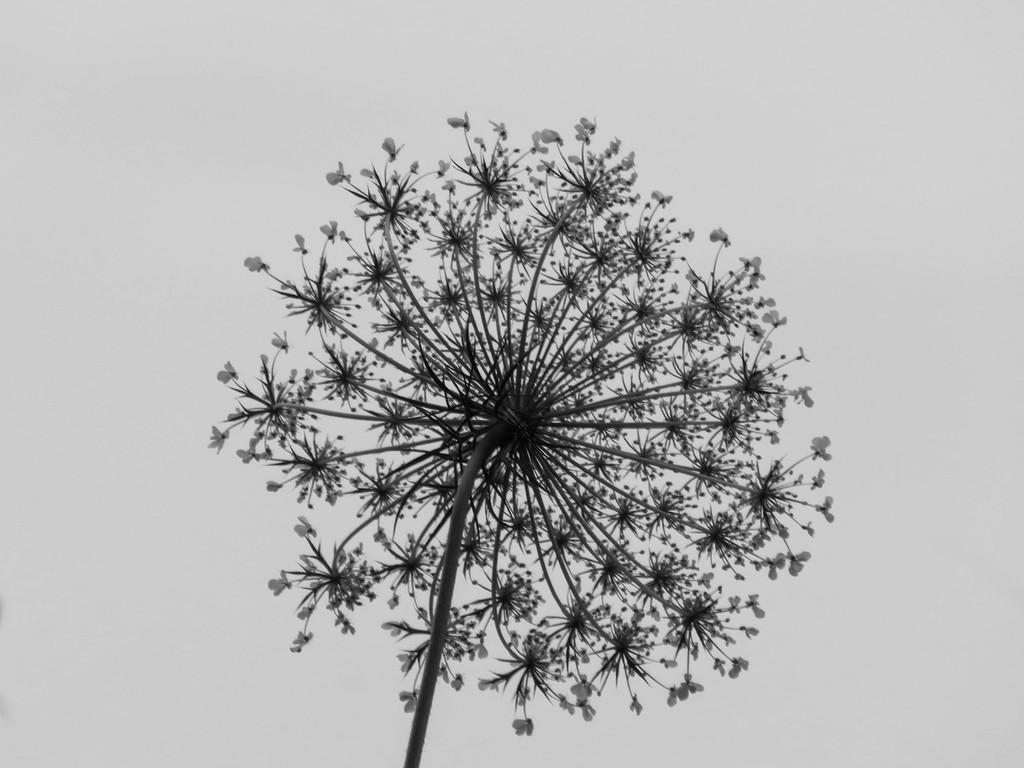What is the color scheme of the image? The image is black and white. What can be seen in the image besides the color scheme? There is a plant in the image. What specific feature of the plant can be observed? The plant has small flowers. What color is the background of the image? The background of the image is white in color. What type of rifle is hanging on the wall in the image? There is no rifle present in the image; it features a black and white plant with small flowers against a white background. 